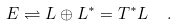<formula> <loc_0><loc_0><loc_500><loc_500>E \rightleftharpoons L \oplus L ^ { \ast } = T ^ { \ast } L \ \ .</formula> 